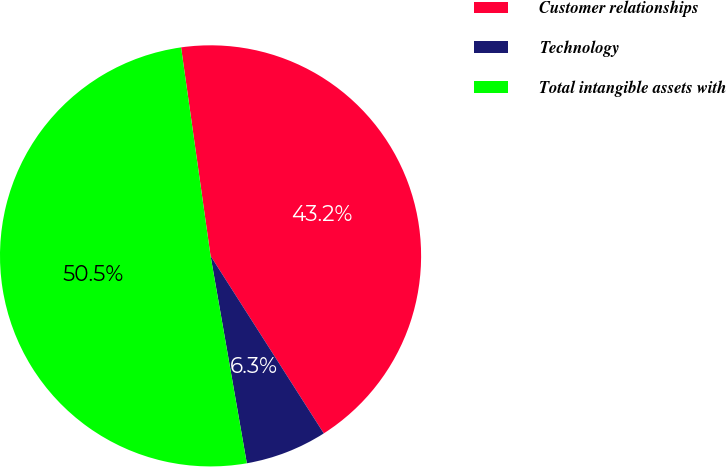Convert chart to OTSL. <chart><loc_0><loc_0><loc_500><loc_500><pie_chart><fcel>Customer relationships<fcel>Technology<fcel>Total intangible assets with<nl><fcel>43.2%<fcel>6.28%<fcel>50.52%<nl></chart> 